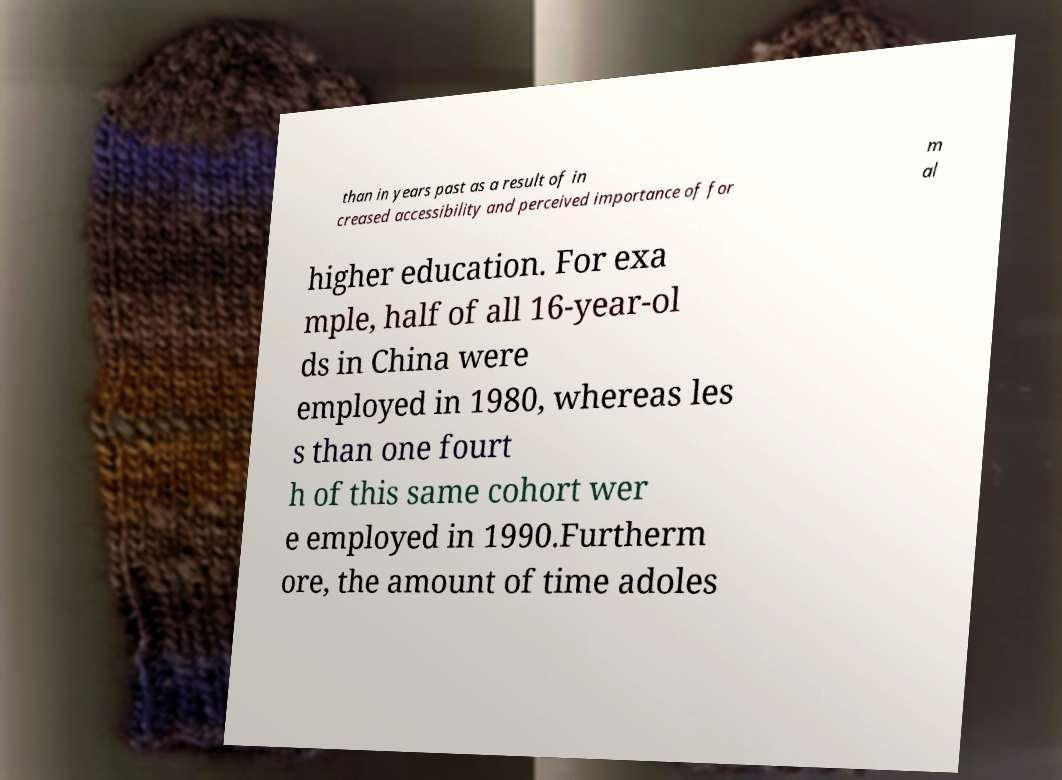Please identify and transcribe the text found in this image. than in years past as a result of in creased accessibility and perceived importance of for m al higher education. For exa mple, half of all 16-year-ol ds in China were employed in 1980, whereas les s than one fourt h of this same cohort wer e employed in 1990.Furtherm ore, the amount of time adoles 